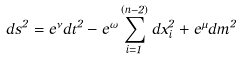<formula> <loc_0><loc_0><loc_500><loc_500>d s ^ { 2 } = e ^ { \nu } d t ^ { 2 } - e ^ { \omega } \sum _ { i = 1 } ^ { ( n - 2 ) } d x _ { i } ^ { 2 } + e ^ { \mu } d m ^ { 2 }</formula> 